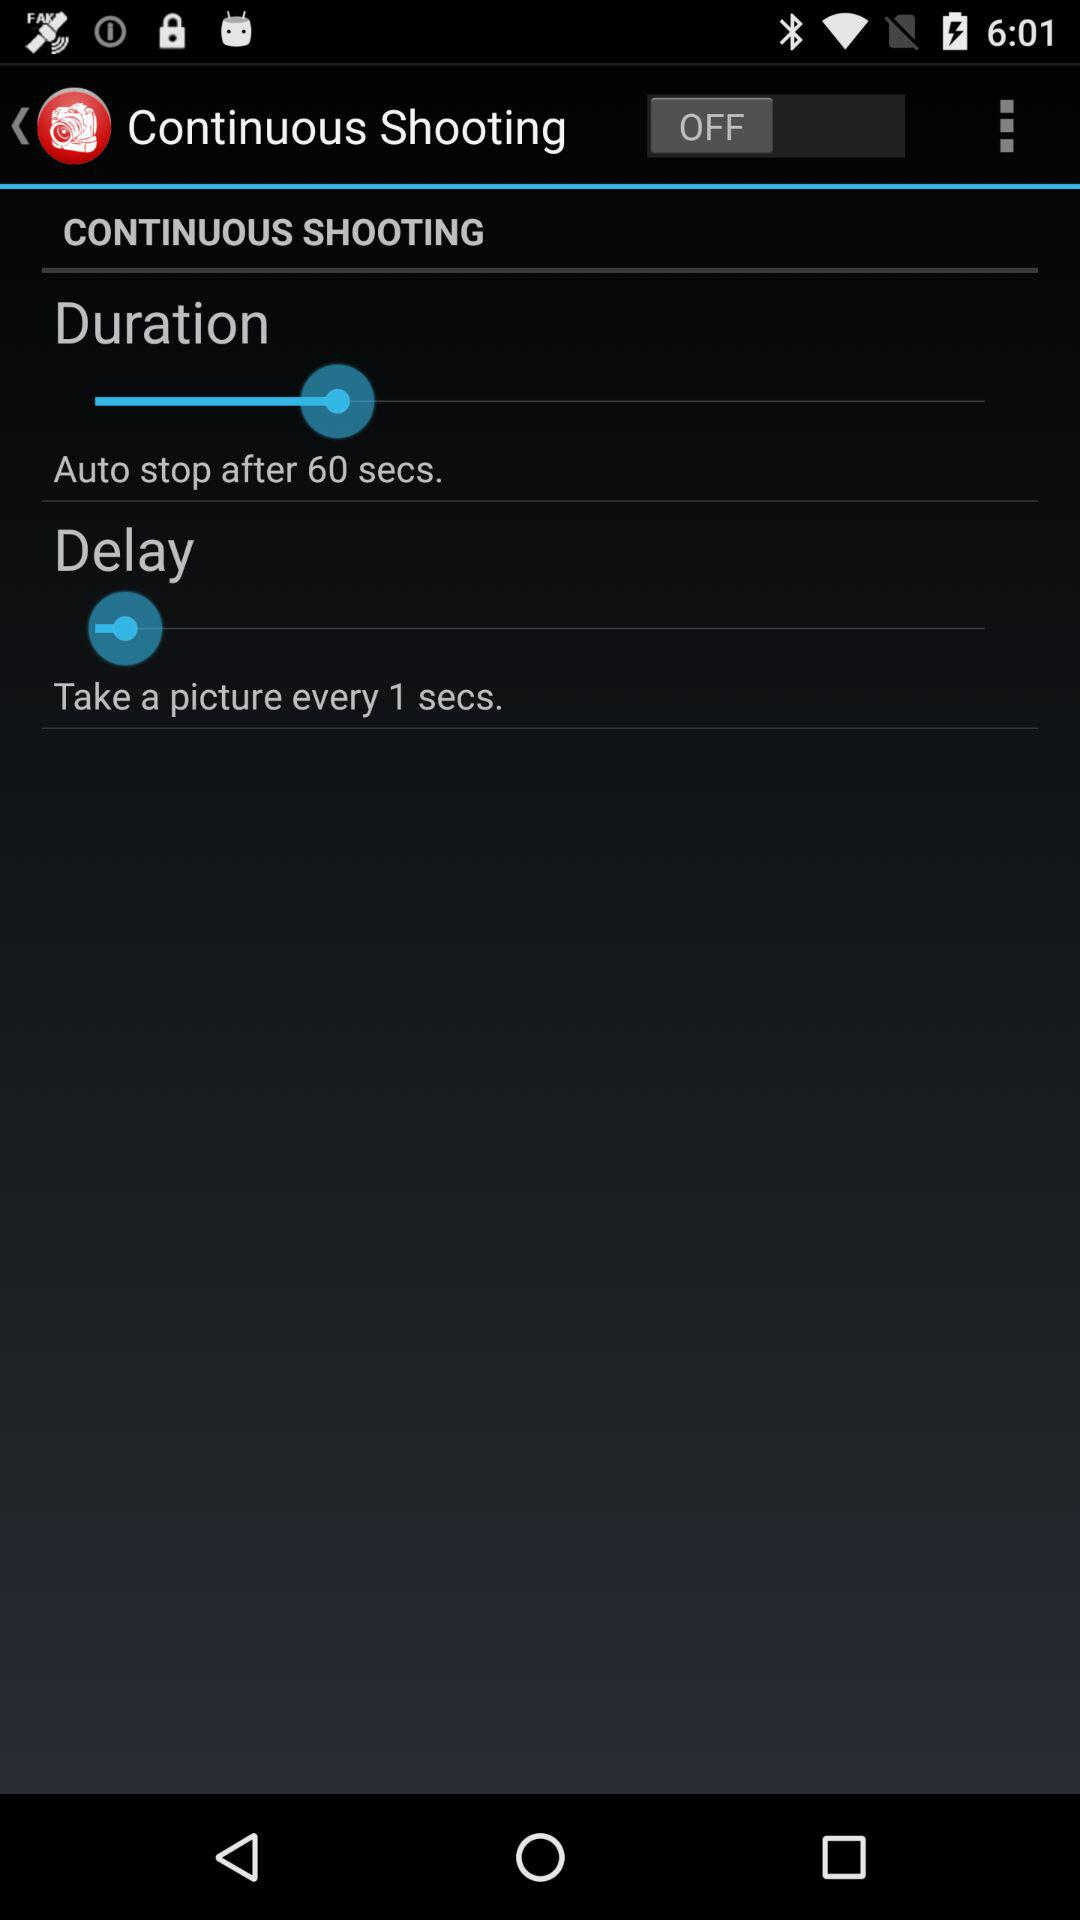How many seconds is the delay between each picture taken?
Answer the question using a single word or phrase. 1 